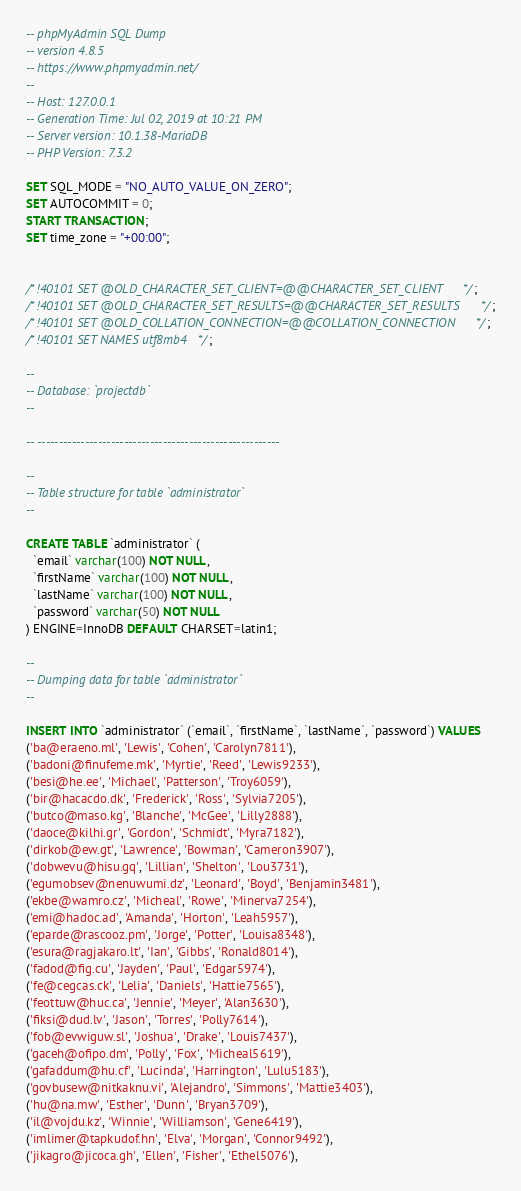Convert code to text. <code><loc_0><loc_0><loc_500><loc_500><_SQL_>-- phpMyAdmin SQL Dump
-- version 4.8.5
-- https://www.phpmyadmin.net/
--
-- Host: 127.0.0.1
-- Generation Time: Jul 02, 2019 at 10:21 PM
-- Server version: 10.1.38-MariaDB
-- PHP Version: 7.3.2

SET SQL_MODE = "NO_AUTO_VALUE_ON_ZERO";
SET AUTOCOMMIT = 0;
START TRANSACTION;
SET time_zone = "+00:00";


/*!40101 SET @OLD_CHARACTER_SET_CLIENT=@@CHARACTER_SET_CLIENT */;
/*!40101 SET @OLD_CHARACTER_SET_RESULTS=@@CHARACTER_SET_RESULTS */;
/*!40101 SET @OLD_COLLATION_CONNECTION=@@COLLATION_CONNECTION */;
/*!40101 SET NAMES utf8mb4 */;

--
-- Database: `projectdb`
--

-- --------------------------------------------------------

--
-- Table structure for table `administrator`
--

CREATE TABLE `administrator` (
  `email` varchar(100) NOT NULL,
  `firstName` varchar(100) NOT NULL,
  `lastName` varchar(100) NOT NULL,
  `password` varchar(50) NOT NULL
) ENGINE=InnoDB DEFAULT CHARSET=latin1;

--
-- Dumping data for table `administrator`
--

INSERT INTO `administrator` (`email`, `firstName`, `lastName`, `password`) VALUES
('ba@eraeno.ml', 'Lewis', 'Cohen', 'Carolyn7811'),
('badoni@finufeme.mk', 'Myrtie', 'Reed', 'Lewis9233'),
('besi@he.ee', 'Michael', 'Patterson', 'Troy6059'),
('bir@hacacdo.dk', 'Frederick', 'Ross', 'Sylvia7205'),
('butco@maso.kg', 'Blanche', 'McGee', 'Lilly2888'),
('daoce@kilhi.gr', 'Gordon', 'Schmidt', 'Myra7182'),
('dirkob@ew.gt', 'Lawrence', 'Bowman', 'Cameron3907'),
('dobwevu@hisu.gq', 'Lillian', 'Shelton', 'Lou3731'),
('egumobsev@nenuwumi.dz', 'Leonard', 'Boyd', 'Benjamin3481'),
('ekbe@wamro.cz', 'Micheal', 'Rowe', 'Minerva7254'),
('emi@hadoc.ad', 'Amanda', 'Horton', 'Leah5957'),
('eparde@rascooz.pm', 'Jorge', 'Potter', 'Louisa8348'),
('esura@ragjakaro.lt', 'Ian', 'Gibbs', 'Ronald8014'),
('fadod@fig.cu', 'Jayden', 'Paul', 'Edgar5974'),
('fe@cegcas.ck', 'Lelia', 'Daniels', 'Hattie7565'),
('feottuw@huc.ca', 'Jennie', 'Meyer', 'Alan3630'),
('fiksi@dud.lv', 'Jason', 'Torres', 'Polly7614'),
('fob@evwiguw.sl', 'Joshua', 'Drake', 'Louis7437'),
('gaceh@ofipo.dm', 'Polly', 'Fox', 'Micheal5619'),
('gafaddum@hu.cf', 'Lucinda', 'Harrington', 'Lulu5183'),
('govbusew@nitkaknu.vi', 'Alejandro', 'Simmons', 'Mattie3403'),
('hu@na.mw', 'Esther', 'Dunn', 'Bryan3709'),
('il@vojdu.kz', 'Winnie', 'Williamson', 'Gene6419'),
('imlimer@tapkudof.hn', 'Elva', 'Morgan', 'Connor9492'),
('jikagro@jicoca.gh', 'Ellen', 'Fisher', 'Ethel5076'),</code> 